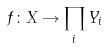Convert formula to latex. <formula><loc_0><loc_0><loc_500><loc_500>f \colon X \rightarrow \prod _ { i } Y _ { i }</formula> 